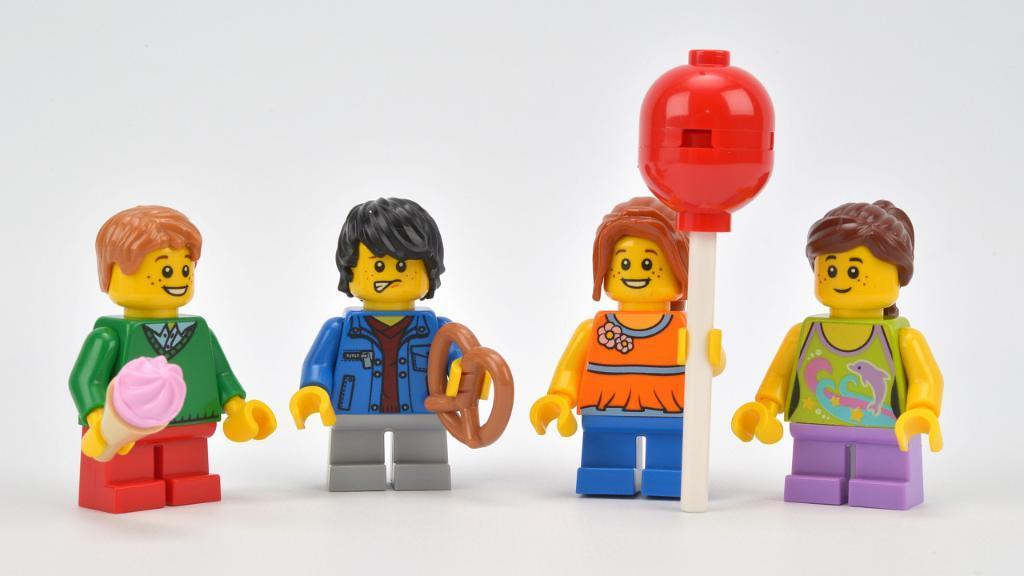How would you summarize this image in a sentence or two? In the image in the center we can see few toys in different colors. And we can see toys holding some objects. 